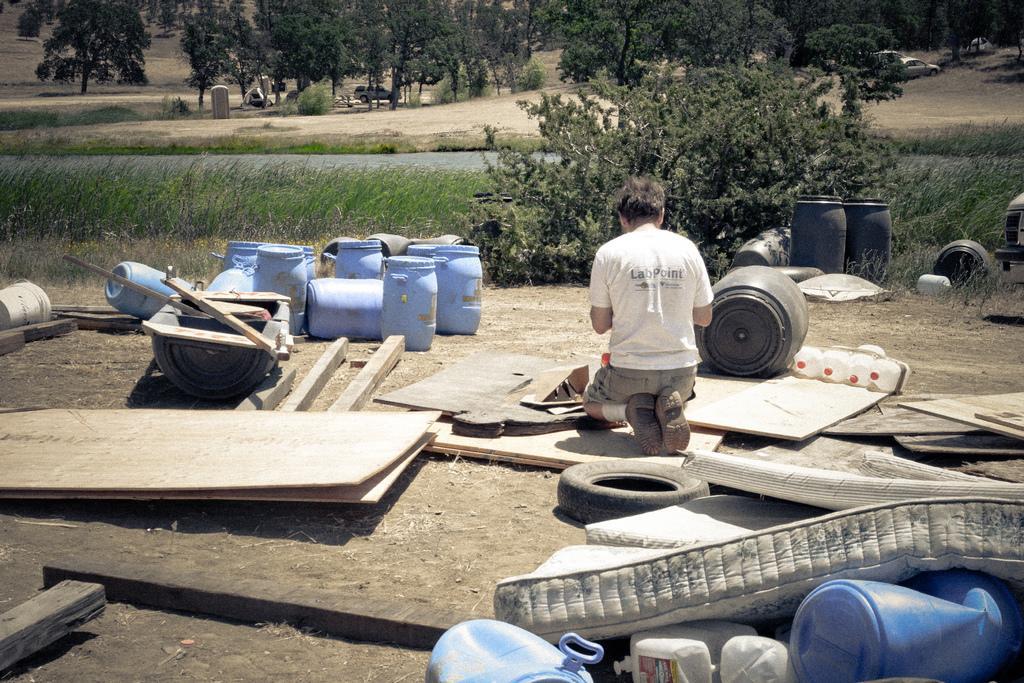In one or two sentences, can you explain what this image depicts? In this image a man is there, he wore white color t-shirt, on the left side there are plastic drums in blue color, at the back side there are trees. 